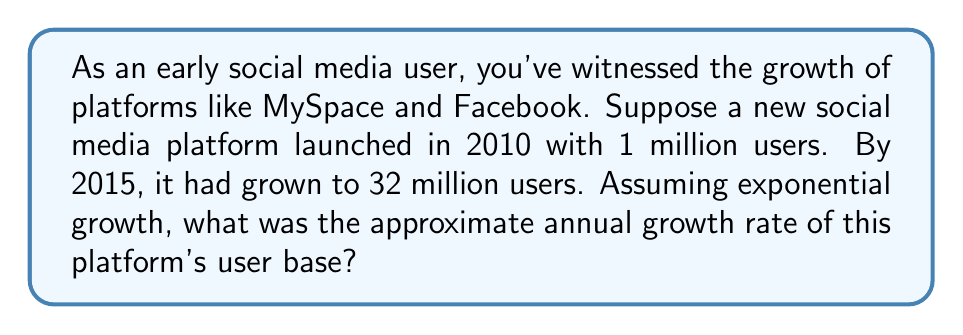Solve this math problem. To solve this problem, we'll use the exponential growth formula:

$$A = P(1 + r)^t$$

Where:
$A$ = Final amount (32 million users)
$P$ = Initial amount (1 million users)
$r$ = Annual growth rate (what we're solving for)
$t$ = Time period (5 years)

Let's plug in the known values:

$$32 = 1(1 + r)^5$$

Now, we'll solve for $r$:

1) Divide both sides by 1:
   $$32 = (1 + r)^5$$

2) Take the 5th root of both sides:
   $$\sqrt[5]{32} = 1 + r$$

3) Simplify the left side:
   $$2 = 1 + r$$

4) Subtract 1 from both sides:
   $$1 = r$$

Therefore, the annual growth rate is 1, or 100%.

To verify:
$$1,000,000 * (1 + 1)^5 = 1,000,000 * 2^5 = 1,000,000 * 32 = 32,000,000$$

This matches our final user count, confirming the calculation.
Answer: The approximate annual growth rate of the social media platform's user base was 100%. 